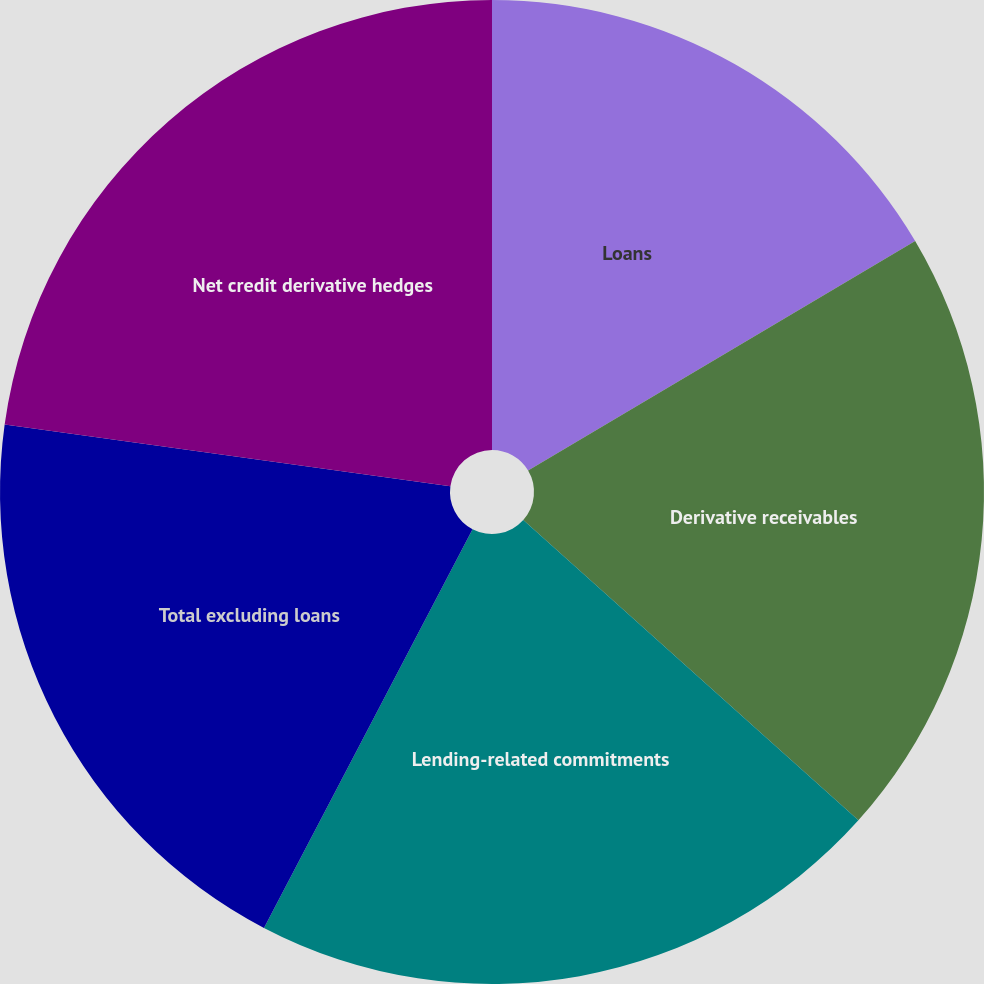Convert chart. <chart><loc_0><loc_0><loc_500><loc_500><pie_chart><fcel>Loans<fcel>Derivative receivables<fcel>Lending-related commitments<fcel>Total excluding loans<fcel>Net credit derivative hedges<nl><fcel>16.48%<fcel>20.15%<fcel>21.04%<fcel>19.52%<fcel>22.81%<nl></chart> 